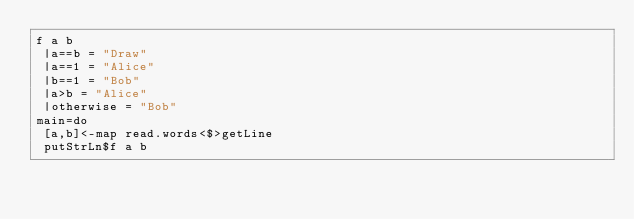Convert code to text. <code><loc_0><loc_0><loc_500><loc_500><_Haskell_>f a b
 |a==b = "Draw"
 |a==1 = "Alice"
 |b==1 = "Bob"
 |a>b = "Alice"
 |otherwise = "Bob"
main=do
 [a,b]<-map read.words<$>getLine
 putStrLn$f a b</code> 